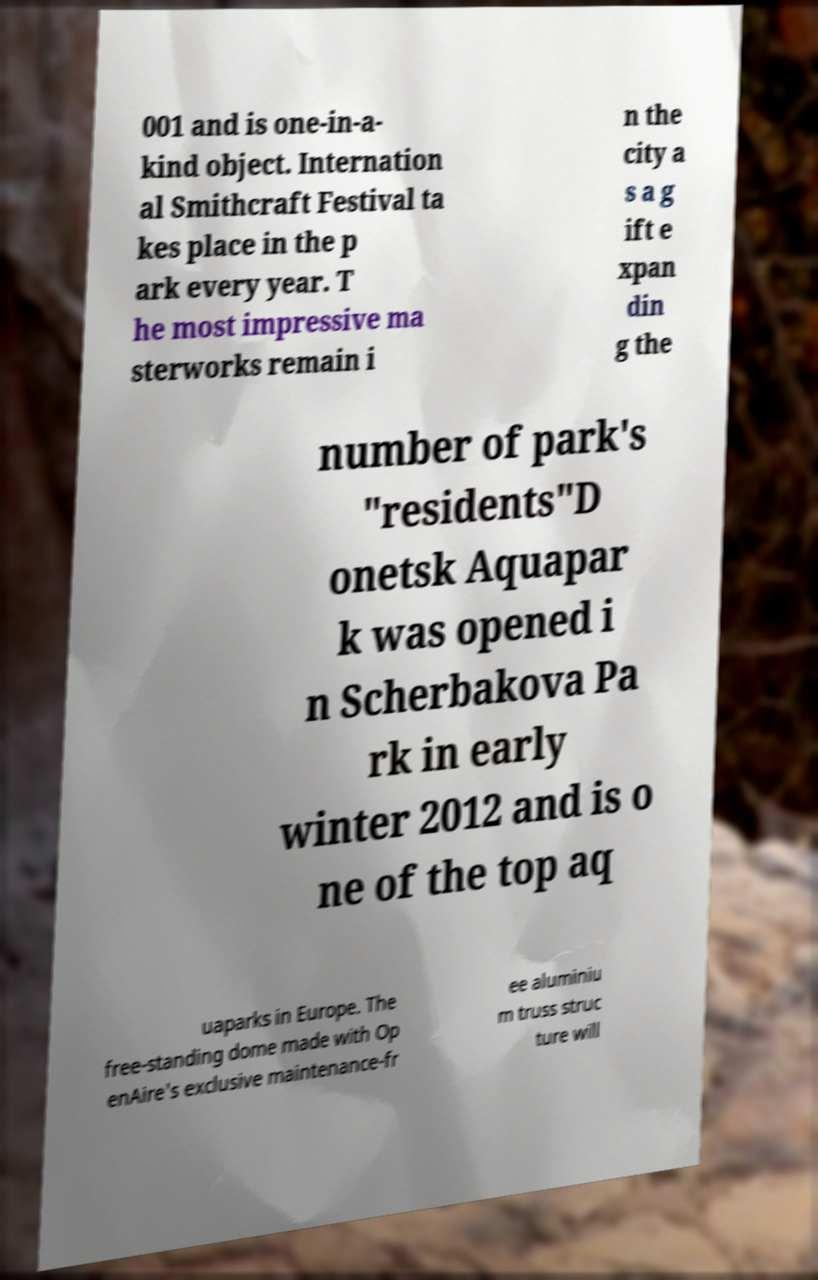Please identify and transcribe the text found in this image. 001 and is one-in-a- kind object. Internation al Smithcraft Festival ta kes place in the p ark every year. T he most impressive ma sterworks remain i n the city a s a g ift e xpan din g the number of park's "residents"D onetsk Aquapar k was opened i n Scherbakova Pa rk in early winter 2012 and is o ne of the top aq uaparks in Europe. The free-standing dome made with Op enAire's exclusive maintenance-fr ee aluminiu m truss struc ture will 